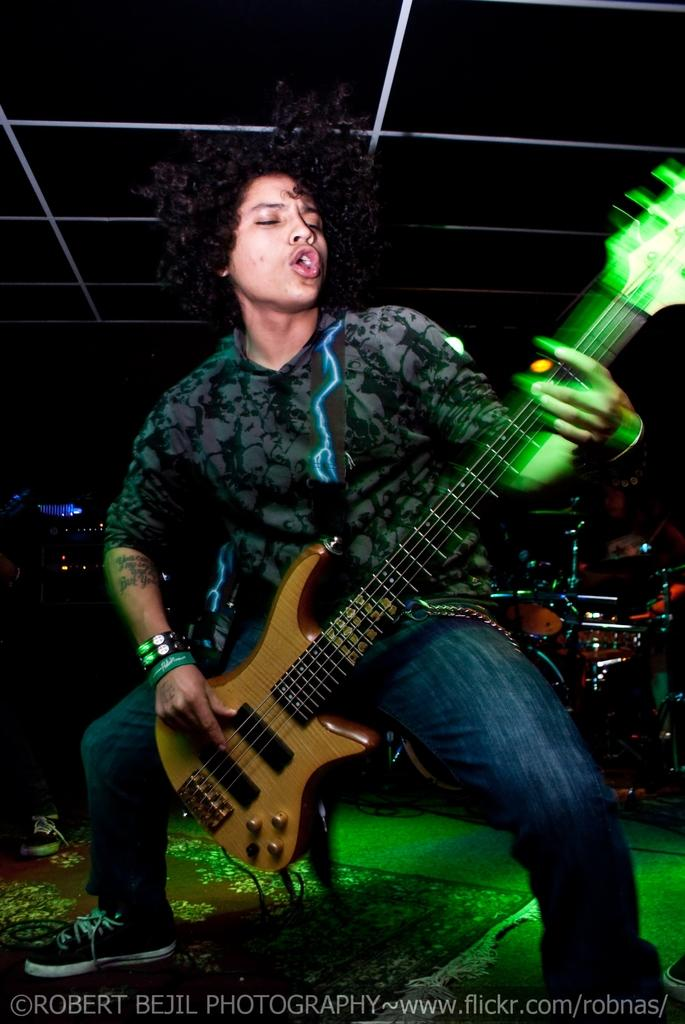What is the main subject of the image? There is a person in the image. What is the person doing in the image? The person is playing the guitar. Where is the cactus located in the image? There is no cactus present in the image. What type of power is being generated by the person playing the guitar? The image does not show any power being generated by the person playing the guitar. 